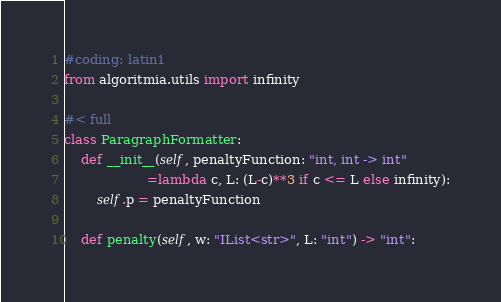<code> <loc_0><loc_0><loc_500><loc_500><_Python_>#coding: latin1
from algoritmia.utils import infinity 

#< full
class ParagraphFormatter:
    def __init__(self, penaltyFunction: "int, int -> int"
                    =lambda c, L: (L-c)**3 if c <= L else infinity):
        self.p = penaltyFunction
        
    def penalty(self, w: "IList<str>", L: "int") -> "int":</code> 